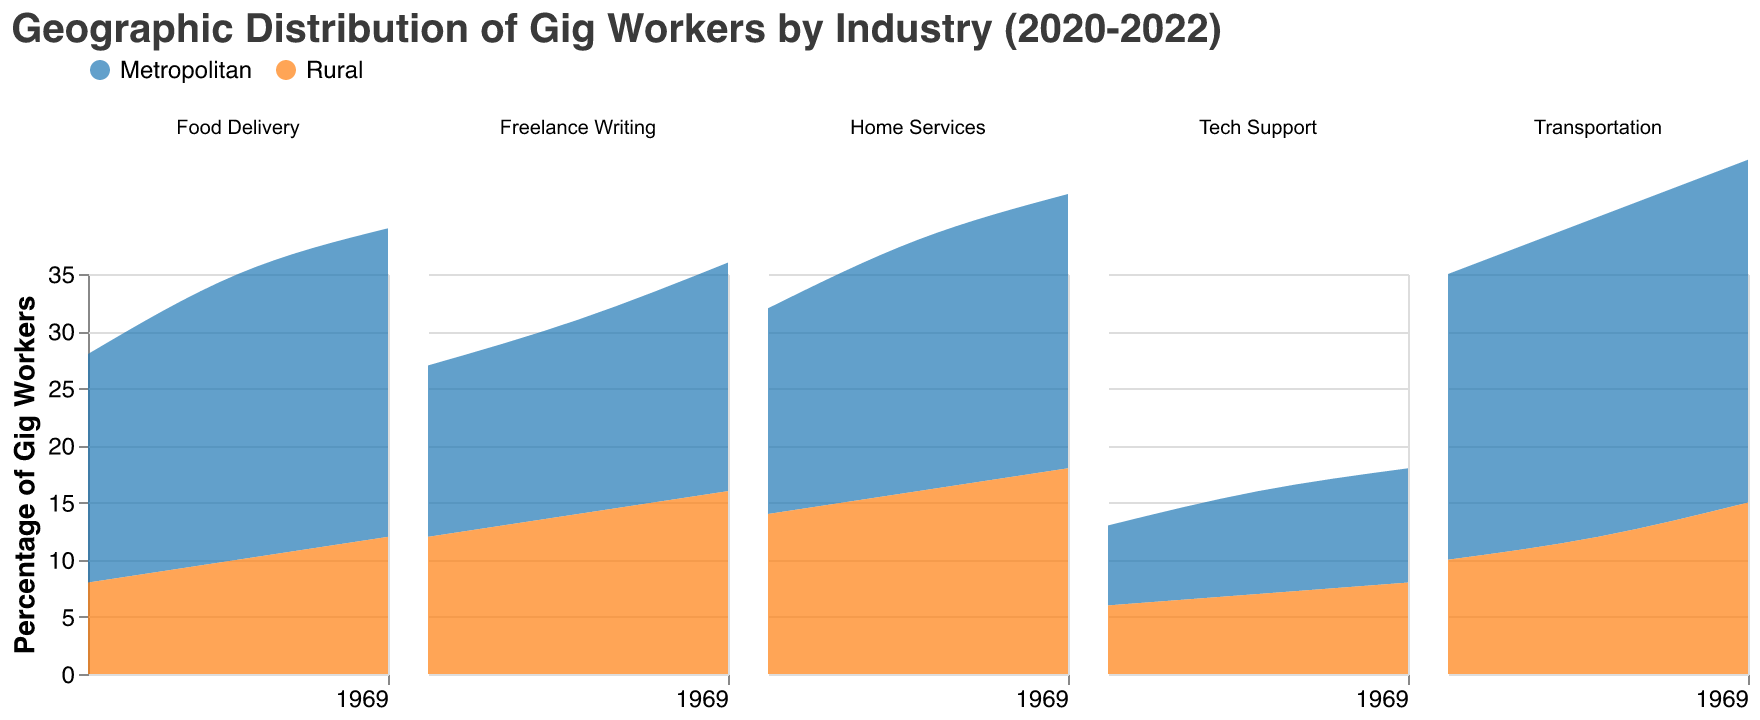What is the title of the figure? The title of the figure is displayed at the top and reads, "Geographic Distribution of Gig Workers by Industry (2020-2022)"
Answer: Geographic Distribution of Gig Workers by Industry (2020-2022) Which industry has the highest percentage of gig workers in the Metropolitan area in 2022? For each subplot, examine the line representing the Metropolitan area in 2022. Notice that the industry “Transportation” has the highest percentage at 30%.
Answer: Transportation How does the percentage of gig workers in the Food Delivery industry change over time in Rural areas? Look at the trend in the Food Delivery subplot for the Rural area. The percentage increases from 8% in 2020 to 10% in 2021 and then to 12% in 2022.
Answer: It increases Which region saw a greater increase in the percentage of gig workers in the Home Services industry from 2020 to 2022? Check the increase in the percentage for the Home Services industry over the period 2020 to 2022 for both regions. Metropolitan increased from 18% to 24% (+6%), while Rural increased from 14% to 18% (+4%).
Answer: Metropolitan In which year did the percentage of gig workers in the Metropolitan area surpass 25% for the Food Delivery industry? Identify the year when the percentage first exceeds 25% in the Metropolitan area for the Food Delivery industry. This occurs in 2021.
Answer: 2021 Compare the trends in the Transportation industry for both Metropolitan and Rural areas. The percentage of gig workers in the Transportation industry shows an upward trend for both regions. In the Metropolitan area, it increases from 25% to 30%, while in Rural areas, it increases from 10% to 15%. Both regions' trends are rising, but Metropolitan starts higher and grows faster.
Answer: Both regions have an upward trend, with Metropolitan growing faster What is the difference in the percentage of gig workers between the Metropolitan and Rural areas for the Tech Support industry in 2022? Subtract the percentage for the Rural region from that for the Metropolitan region in 2022 in the Tech Support industry. The difference is 10% - 8% = 2%.
Answer: 2% Which industry has the smallest difference in the percentage of gig workers between Metropolitan and Rural areas in 2020? Calculate the differences for each industry in 2020: Transportation (15%), Food Delivery (12%), Freelance Writing (3%), Home Services (4%), Tech Support (1%). The smallest difference is for Tech Support.
Answer: Tech Support Between 2021 and 2022, which region had a higher relative growth in the percentage of gig workers for the Freelance Writing industry? Calculate the relative growth for each region. Metropolitan: (20%-17%)/17% = 3/17 = 0.176 (approx. 17.6%); Rural: (16%-14%)/14% = 2/14 = 0.143 (approx. 14.3%). Metropolitan had a higher relative growth.
Answer: Metropolitan 